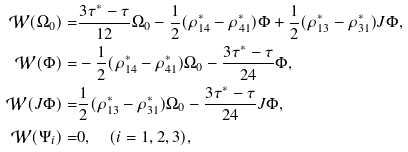<formula> <loc_0><loc_0><loc_500><loc_500>\mathcal { W } ( \Omega _ { 0 } ) = & \frac { 3 \tau ^ { * } - \tau } { 1 2 } \Omega _ { 0 } - \frac { 1 } { 2 } ( \rho ^ { * } _ { 1 4 } - \rho ^ { * } _ { 4 1 } ) \Phi + \frac { 1 } { 2 } ( \rho ^ { * } _ { 1 3 } - \rho ^ { * } _ { 3 1 } ) J \Phi , \\ \mathcal { W } ( \Phi ) = & - \frac { 1 } { 2 } ( \rho ^ { * } _ { 1 4 } - \rho ^ { * } _ { 4 1 } ) \Omega _ { 0 } - \frac { 3 \tau ^ { * } - \tau } { 2 4 } \Phi , \\ \mathcal { W } ( J \Phi ) = & \frac { 1 } { 2 } ( \rho ^ { * } _ { 1 3 } - \rho ^ { * } _ { 3 1 } ) \Omega _ { 0 } - \frac { 3 \tau ^ { * } - \tau } { 2 4 } J \Phi , \\ \mathcal { W } ( \Psi _ { i } ) = & 0 , \quad ( i = 1 , 2 , 3 ) ,</formula> 